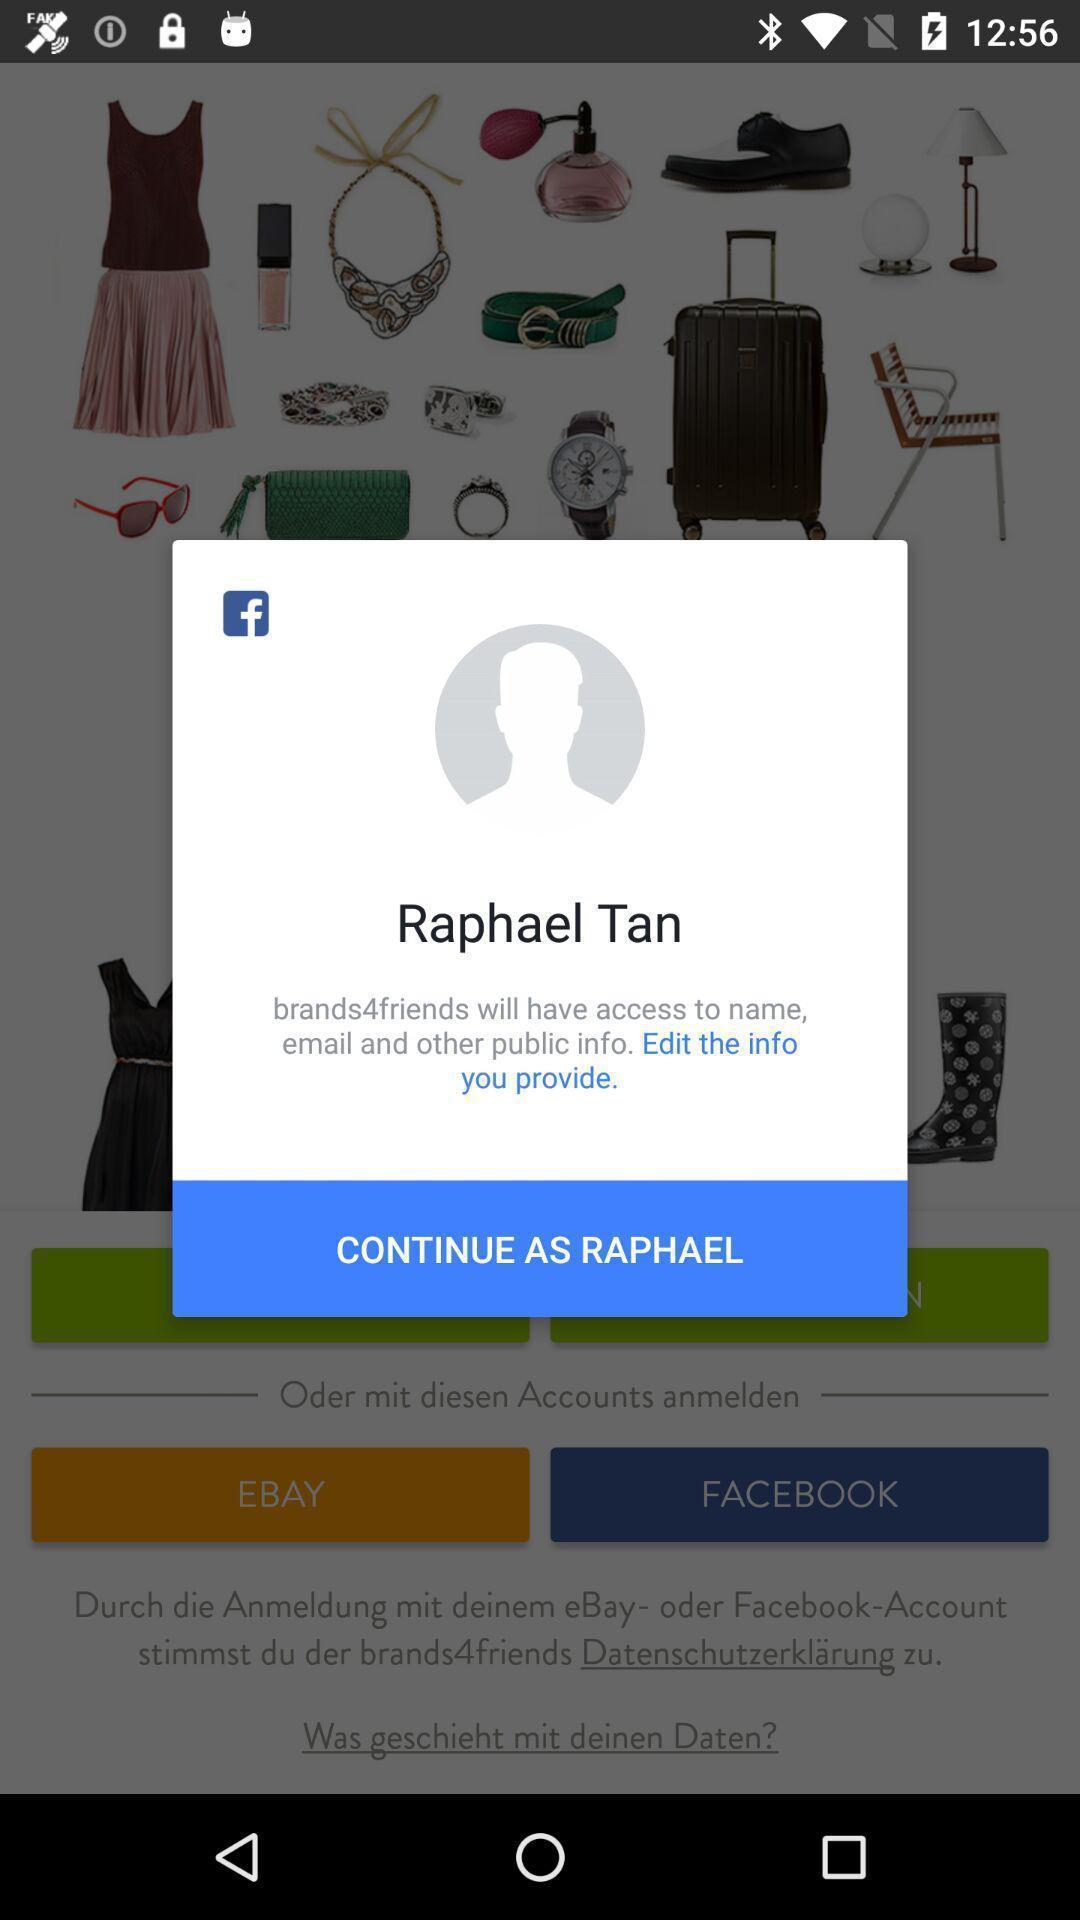Summarize the main components in this picture. Pop-up showing to continue in shopping app. 